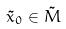<formula> <loc_0><loc_0><loc_500><loc_500>\tilde { x } _ { 0 } \in \tilde { M }</formula> 